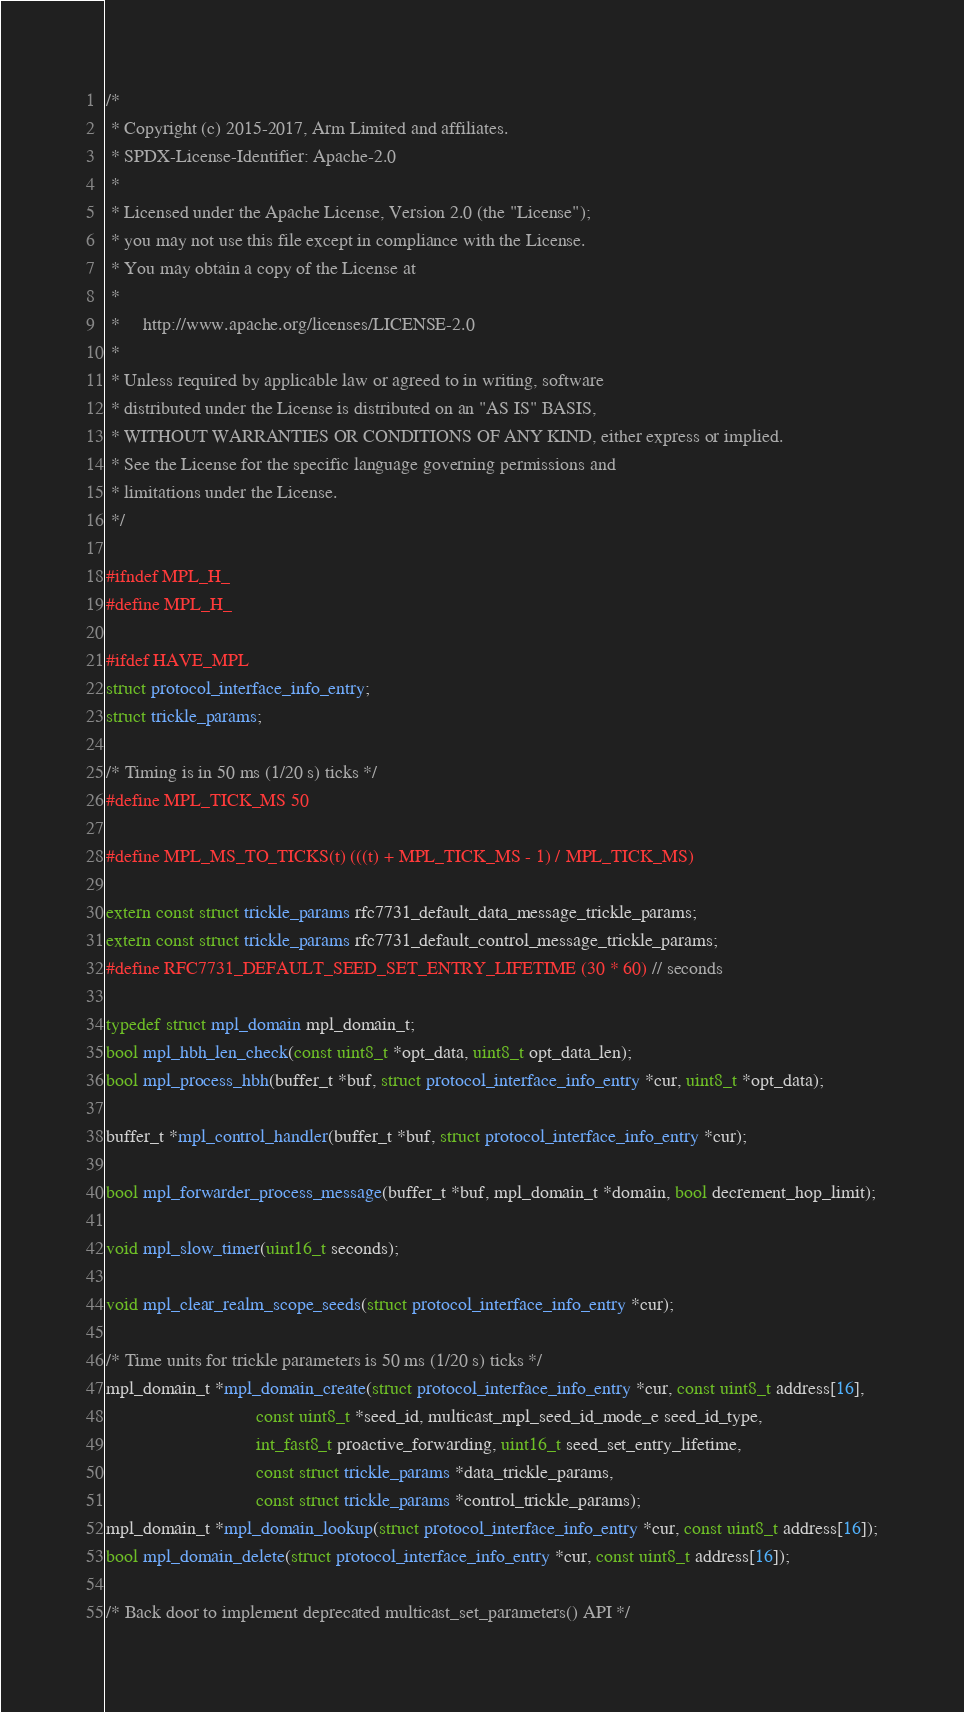<code> <loc_0><loc_0><loc_500><loc_500><_C_>/*
 * Copyright (c) 2015-2017, Arm Limited and affiliates.
 * SPDX-License-Identifier: Apache-2.0
 *
 * Licensed under the Apache License, Version 2.0 (the "License");
 * you may not use this file except in compliance with the License.
 * You may obtain a copy of the License at
 *
 *     http://www.apache.org/licenses/LICENSE-2.0
 *
 * Unless required by applicable law or agreed to in writing, software
 * distributed under the License is distributed on an "AS IS" BASIS,
 * WITHOUT WARRANTIES OR CONDITIONS OF ANY KIND, either express or implied.
 * See the License for the specific language governing permissions and
 * limitations under the License.
 */

#ifndef MPL_H_
#define MPL_H_

#ifdef HAVE_MPL
struct protocol_interface_info_entry;
struct trickle_params;

/* Timing is in 50 ms (1/20 s) ticks */
#define MPL_TICK_MS 50

#define MPL_MS_TO_TICKS(t) (((t) + MPL_TICK_MS - 1) / MPL_TICK_MS)

extern const struct trickle_params rfc7731_default_data_message_trickle_params;
extern const struct trickle_params rfc7731_default_control_message_trickle_params;
#define RFC7731_DEFAULT_SEED_SET_ENTRY_LIFETIME (30 * 60) // seconds

typedef struct mpl_domain mpl_domain_t;
bool mpl_hbh_len_check(const uint8_t *opt_data, uint8_t opt_data_len);
bool mpl_process_hbh(buffer_t *buf, struct protocol_interface_info_entry *cur, uint8_t *opt_data);

buffer_t *mpl_control_handler(buffer_t *buf, struct protocol_interface_info_entry *cur);

bool mpl_forwarder_process_message(buffer_t *buf, mpl_domain_t *domain, bool decrement_hop_limit);

void mpl_slow_timer(uint16_t seconds);

void mpl_clear_realm_scope_seeds(struct protocol_interface_info_entry *cur);

/* Time units for trickle parameters is 50 ms (1/20 s) ticks */
mpl_domain_t *mpl_domain_create(struct protocol_interface_info_entry *cur, const uint8_t address[16],
                                const uint8_t *seed_id, multicast_mpl_seed_id_mode_e seed_id_type,
                                int_fast8_t proactive_forwarding, uint16_t seed_set_entry_lifetime,
                                const struct trickle_params *data_trickle_params,
                                const struct trickle_params *control_trickle_params);
mpl_domain_t *mpl_domain_lookup(struct protocol_interface_info_entry *cur, const uint8_t address[16]);
bool mpl_domain_delete(struct protocol_interface_info_entry *cur, const uint8_t address[16]);

/* Back door to implement deprecated multicast_set_parameters() API */</code> 